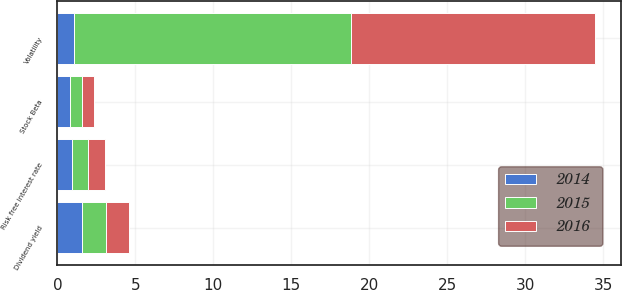<chart> <loc_0><loc_0><loc_500><loc_500><stacked_bar_chart><ecel><fcel>Volatility<fcel>Risk free interest rate<fcel>Dividend yield<fcel>Stock Beta<nl><fcel>2016<fcel>15.6<fcel>1.06<fcel>1.5<fcel>0.74<nl><fcel>2015<fcel>17.8<fcel>1.06<fcel>1.5<fcel>0.77<nl><fcel>2014<fcel>1.06<fcel>0.91<fcel>1.6<fcel>0.84<nl></chart> 